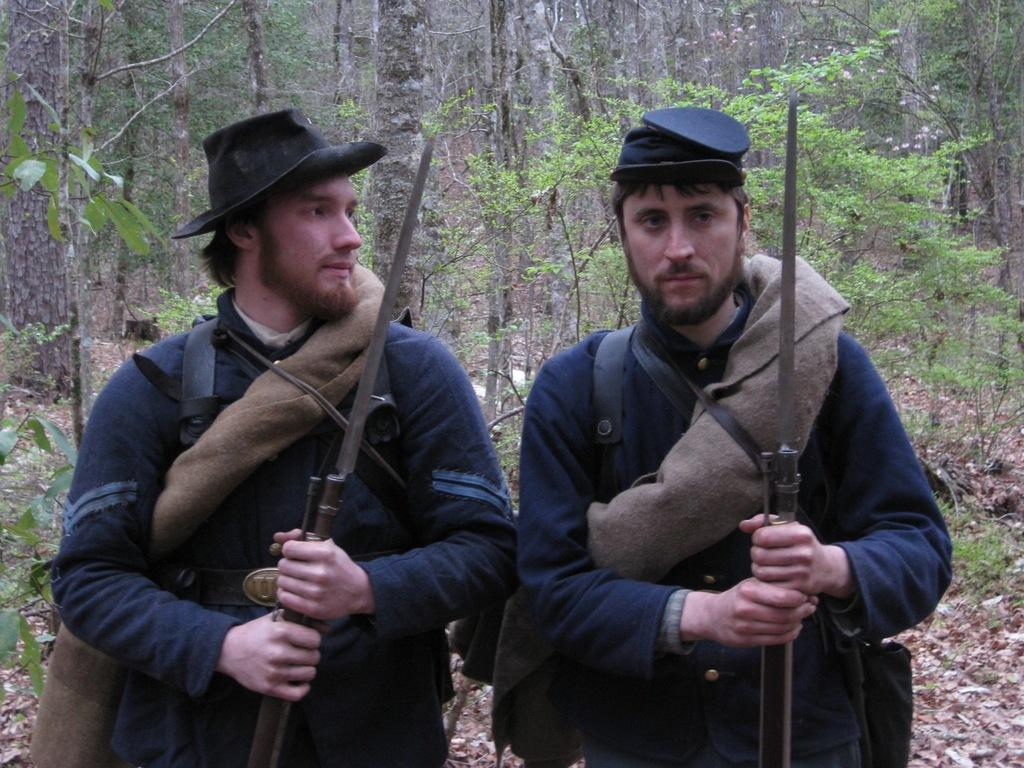How many people are in the image? There are two persons in the image. What are the persons doing in the image? The persons are standing and holding rifles. What can be seen in the background of the image? There are trees in the background of the image. What type of celery can be seen growing near the persons in the image? There is no celery present in the image. How many cars are visible in the image? There are no cars visible in the image. 